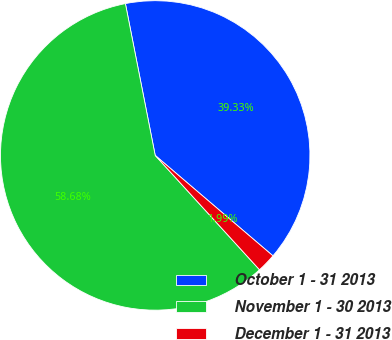Convert chart. <chart><loc_0><loc_0><loc_500><loc_500><pie_chart><fcel>October 1 - 31 2013<fcel>November 1 - 30 2013<fcel>December 1 - 31 2013<nl><fcel>39.33%<fcel>58.69%<fcel>1.99%<nl></chart> 